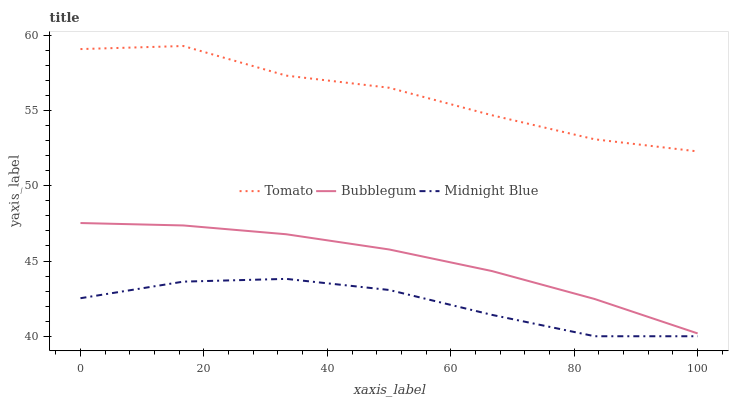Does Bubblegum have the minimum area under the curve?
Answer yes or no. No. Does Bubblegum have the maximum area under the curve?
Answer yes or no. No. Is Midnight Blue the smoothest?
Answer yes or no. No. Is Midnight Blue the roughest?
Answer yes or no. No. Does Bubblegum have the lowest value?
Answer yes or no. No. Does Bubblegum have the highest value?
Answer yes or no. No. Is Midnight Blue less than Tomato?
Answer yes or no. Yes. Is Bubblegum greater than Midnight Blue?
Answer yes or no. Yes. Does Midnight Blue intersect Tomato?
Answer yes or no. No. 